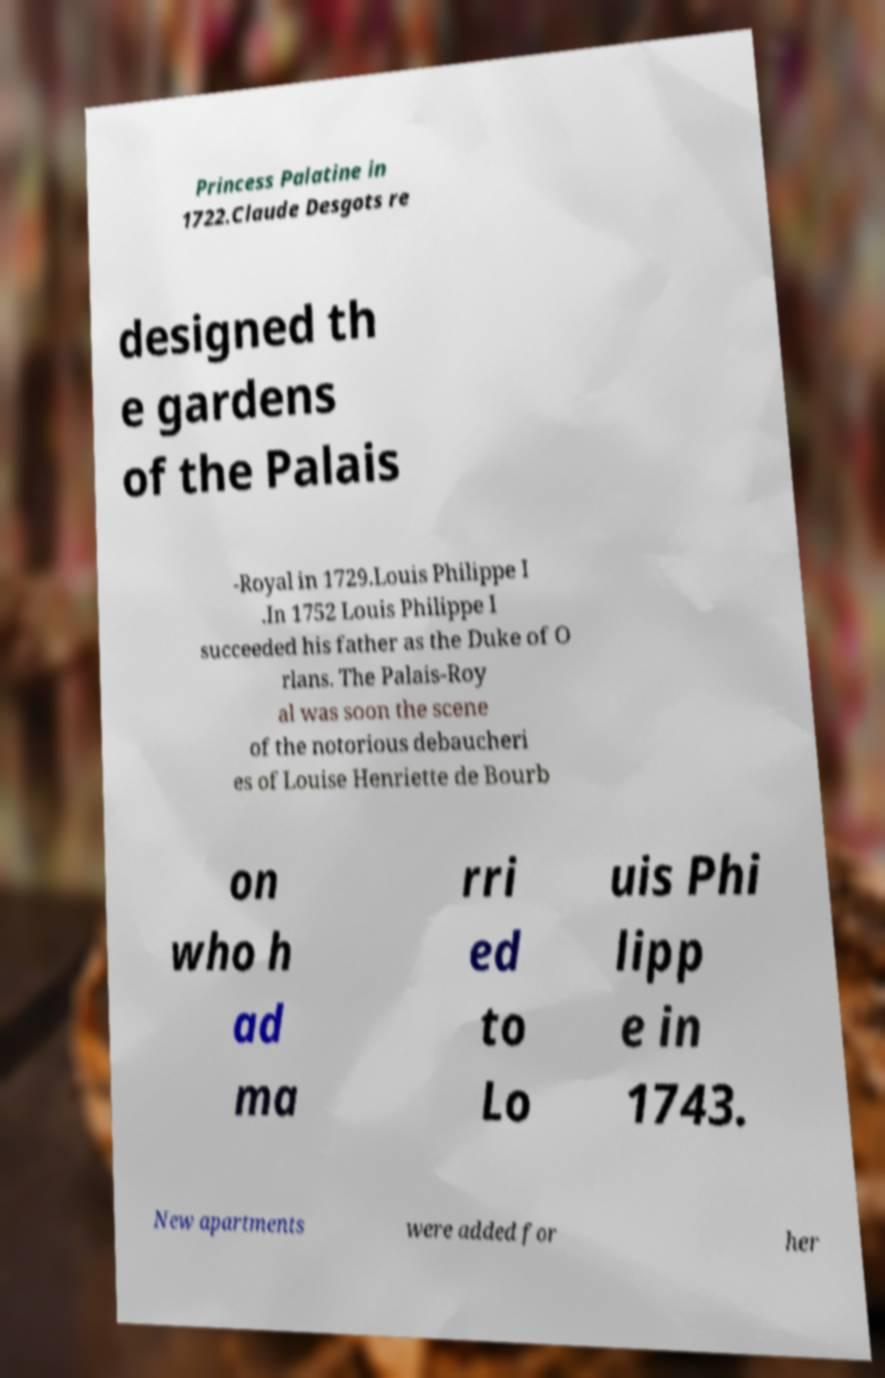Please identify and transcribe the text found in this image. Princess Palatine in 1722.Claude Desgots re designed th e gardens of the Palais -Royal in 1729.Louis Philippe I .In 1752 Louis Philippe I succeeded his father as the Duke of O rlans. The Palais-Roy al was soon the scene of the notorious debaucheri es of Louise Henriette de Bourb on who h ad ma rri ed to Lo uis Phi lipp e in 1743. New apartments were added for her 